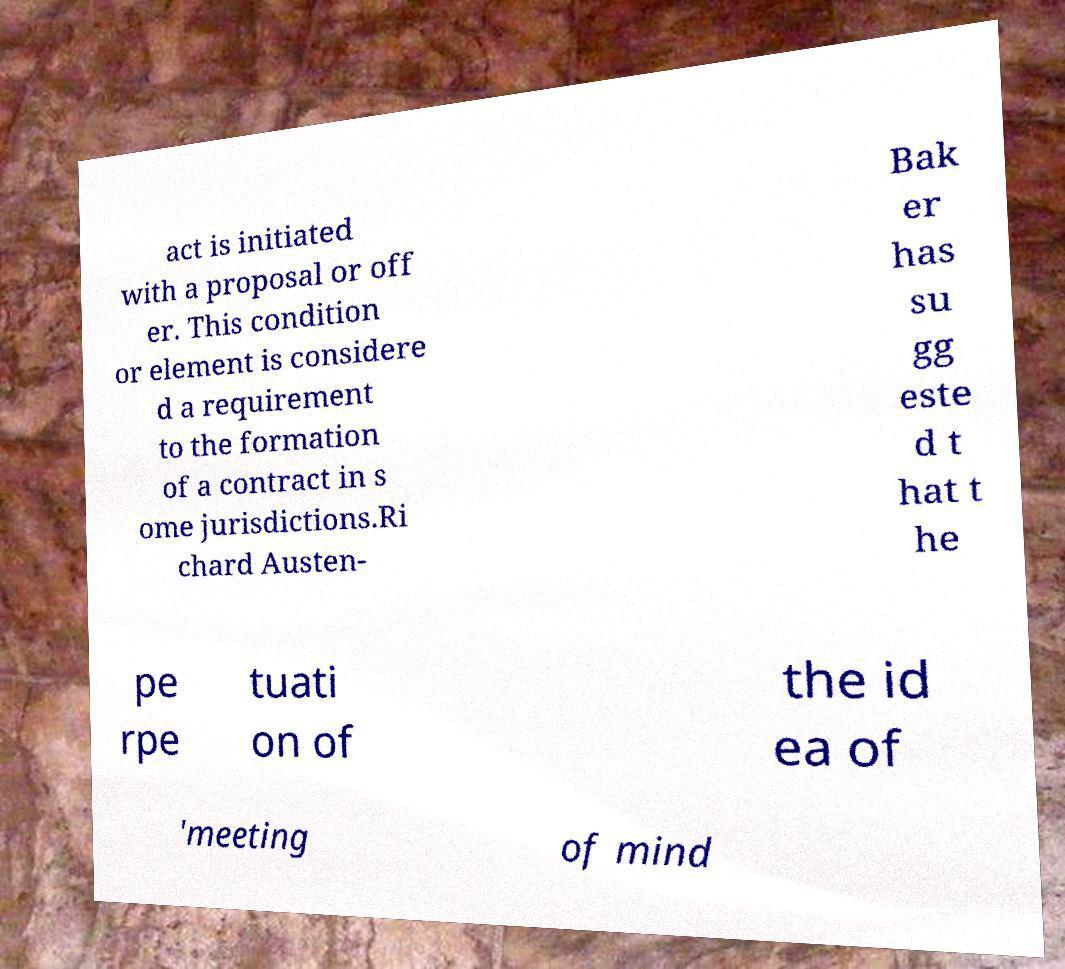Can you read and provide the text displayed in the image?This photo seems to have some interesting text. Can you extract and type it out for me? act is initiated with a proposal or off er. This condition or element is considere d a requirement to the formation of a contract in s ome jurisdictions.Ri chard Austen- Bak er has su gg este d t hat t he pe rpe tuati on of the id ea of 'meeting of mind 